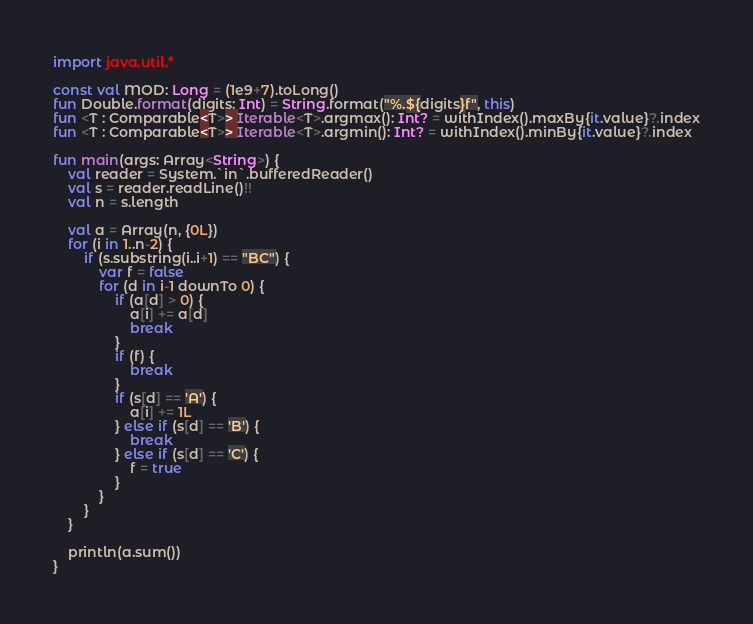Convert code to text. <code><loc_0><loc_0><loc_500><loc_500><_Kotlin_>import java.util.*

const val MOD: Long = (1e9+7).toLong()
fun Double.format(digits: Int) = String.format("%.${digits}f", this)
fun <T : Comparable<T>> Iterable<T>.argmax(): Int? = withIndex().maxBy{it.value}?.index
fun <T : Comparable<T>> Iterable<T>.argmin(): Int? = withIndex().minBy{it.value}?.index

fun main(args: Array<String>) {
    val reader = System.`in`.bufferedReader()
    val s = reader.readLine()!!
    val n = s.length

    val a = Array(n, {0L})
    for (i in 1..n-2) {
        if (s.substring(i..i+1) == "BC") {
            var f = false
            for (d in i-1 downTo 0) {
                if (a[d] > 0) {
                    a[i] += a[d]
                    break
                }
                if (f) {
                    break
                }
                if (s[d] == 'A') {
                    a[i] += 1L
                } else if (s[d] == 'B') {
                    break
                } else if (s[d] == 'C') {
                    f = true
                }
            }
        }
    }

    println(a.sum())
}
</code> 